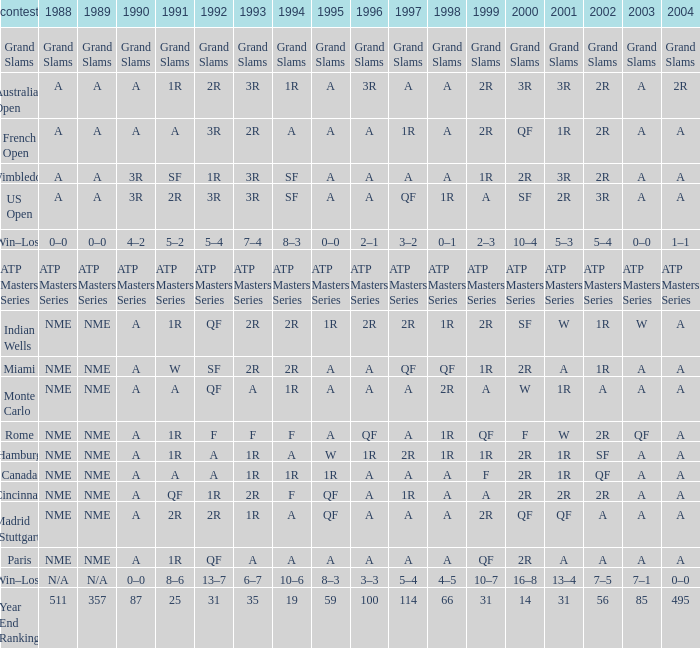What shows for 1992 when 2001 is 1r, 1994 is 1r, and the 2002 is qf? A. Could you parse the entire table? {'header': ['contest', '1988', '1989', '1990', '1991', '1992', '1993', '1994', '1995', '1996', '1997', '1998', '1999', '2000', '2001', '2002', '2003', '2004'], 'rows': [['Grand Slams', 'Grand Slams', 'Grand Slams', 'Grand Slams', 'Grand Slams', 'Grand Slams', 'Grand Slams', 'Grand Slams', 'Grand Slams', 'Grand Slams', 'Grand Slams', 'Grand Slams', 'Grand Slams', 'Grand Slams', 'Grand Slams', 'Grand Slams', 'Grand Slams', 'Grand Slams'], ['Australian Open', 'A', 'A', 'A', '1R', '2R', '3R', '1R', 'A', '3R', 'A', 'A', '2R', '3R', '3R', '2R', 'A', '2R'], ['French Open', 'A', 'A', 'A', 'A', '3R', '2R', 'A', 'A', 'A', '1R', 'A', '2R', 'QF', '1R', '2R', 'A', 'A'], ['Wimbledon', 'A', 'A', '3R', 'SF', '1R', '3R', 'SF', 'A', 'A', 'A', 'A', '1R', '2R', '3R', '2R', 'A', 'A'], ['US Open', 'A', 'A', '3R', '2R', '3R', '3R', 'SF', 'A', 'A', 'QF', '1R', 'A', 'SF', '2R', '3R', 'A', 'A'], ['Win–Loss', '0–0', '0–0', '4–2', '5–2', '5–4', '7–4', '8–3', '0–0', '2–1', '3–2', '0–1', '2–3', '10–4', '5–3', '5–4', '0–0', '1–1'], ['ATP Masters Series', 'ATP Masters Series', 'ATP Masters Series', 'ATP Masters Series', 'ATP Masters Series', 'ATP Masters Series', 'ATP Masters Series', 'ATP Masters Series', 'ATP Masters Series', 'ATP Masters Series', 'ATP Masters Series', 'ATP Masters Series', 'ATP Masters Series', 'ATP Masters Series', 'ATP Masters Series', 'ATP Masters Series', 'ATP Masters Series', 'ATP Masters Series'], ['Indian Wells', 'NME', 'NME', 'A', '1R', 'QF', '2R', '2R', '1R', '2R', '2R', '1R', '2R', 'SF', 'W', '1R', 'W', 'A'], ['Miami', 'NME', 'NME', 'A', 'W', 'SF', '2R', '2R', 'A', 'A', 'QF', 'QF', '1R', '2R', 'A', '1R', 'A', 'A'], ['Monte Carlo', 'NME', 'NME', 'A', 'A', 'QF', 'A', '1R', 'A', 'A', 'A', '2R', 'A', 'W', '1R', 'A', 'A', 'A'], ['Rome', 'NME', 'NME', 'A', '1R', 'F', 'F', 'F', 'A', 'QF', 'A', '1R', 'QF', 'F', 'W', '2R', 'QF', 'A'], ['Hamburg', 'NME', 'NME', 'A', '1R', 'A', '1R', 'A', 'W', '1R', '2R', '1R', '1R', '2R', '1R', 'SF', 'A', 'A'], ['Canada', 'NME', 'NME', 'A', 'A', 'A', '1R', '1R', '1R', 'A', 'A', 'A', 'F', '2R', '1R', 'QF', 'A', 'A'], ['Cincinnati', 'NME', 'NME', 'A', 'QF', '1R', '2R', 'F', 'QF', 'A', '1R', 'A', 'A', '2R', '2R', '2R', 'A', 'A'], ['Madrid (Stuttgart)', 'NME', 'NME', 'A', '2R', '2R', '1R', 'A', 'QF', 'A', 'A', 'A', '2R', 'QF', 'QF', 'A', 'A', 'A'], ['Paris', 'NME', 'NME', 'A', '1R', 'QF', 'A', 'A', 'A', 'A', 'A', 'A', 'QF', '2R', 'A', 'A', 'A', 'A'], ['Win–Loss', 'N/A', 'N/A', '0–0', '8–6', '13–7', '6–7', '10–6', '8–3', '3–3', '5–4', '4–5', '10–7', '16–8', '13–4', '7–5', '7–1', '0–0'], ['Year End Ranking', '511', '357', '87', '25', '31', '35', '19', '59', '100', '114', '66', '31', '14', '31', '56', '85', '495']]} 